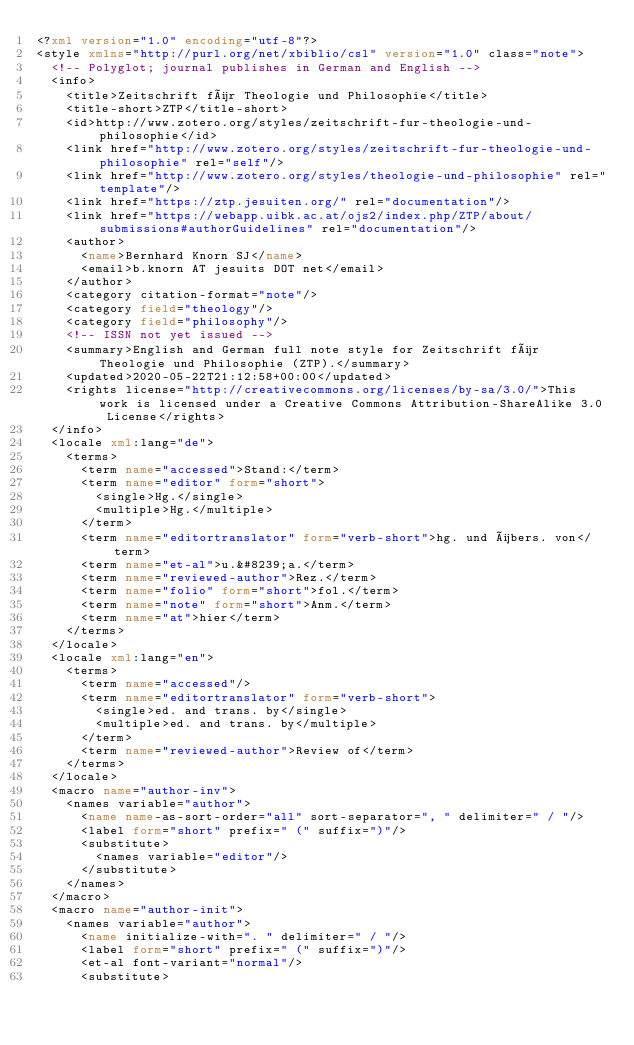<code> <loc_0><loc_0><loc_500><loc_500><_XML_><?xml version="1.0" encoding="utf-8"?>
<style xmlns="http://purl.org/net/xbiblio/csl" version="1.0" class="note">
  <!-- Polyglot; journal publishes in German and English -->
  <info>
    <title>Zeitschrift für Theologie und Philosophie</title>
    <title-short>ZTP</title-short>
    <id>http://www.zotero.org/styles/zeitschrift-fur-theologie-und-philosophie</id>
    <link href="http://www.zotero.org/styles/zeitschrift-fur-theologie-und-philosophie" rel="self"/>
    <link href="http://www.zotero.org/styles/theologie-und-philosophie" rel="template"/>
    <link href="https://ztp.jesuiten.org/" rel="documentation"/>
    <link href="https://webapp.uibk.ac.at/ojs2/index.php/ZTP/about/submissions#authorGuidelines" rel="documentation"/>
    <author>
      <name>Bernhard Knorn SJ</name>
      <email>b.knorn AT jesuits DOT net</email>
    </author>
    <category citation-format="note"/>
    <category field="theology"/>
    <category field="philosophy"/>
    <!-- ISSN not yet issued -->
    <summary>English and German full note style for Zeitschrift für Theologie und Philosophie (ZTP).</summary>
    <updated>2020-05-22T21:12:58+00:00</updated>
    <rights license="http://creativecommons.org/licenses/by-sa/3.0/">This work is licensed under a Creative Commons Attribution-ShareAlike 3.0 License</rights>
  </info>
  <locale xml:lang="de">
    <terms>
      <term name="accessed">Stand:</term>
      <term name="editor" form="short">
        <single>Hg.</single>
        <multiple>Hg.</multiple>
      </term>
      <term name="editortranslator" form="verb-short">hg. und übers. von</term>
      <term name="et-al">u.&#8239;a.</term>
      <term name="reviewed-author">Rez.</term>
      <term name="folio" form="short">fol.</term>
      <term name="note" form="short">Anm.</term>
      <term name="at">hier</term>
    </terms>
  </locale>
  <locale xml:lang="en">
    <terms>
      <term name="accessed"/>
      <term name="editortranslator" form="verb-short">
        <single>ed. and trans. by</single>
        <multiple>ed. and trans. by</multiple>
      </term>
      <term name="reviewed-author">Review of</term>
    </terms>
  </locale>
  <macro name="author-inv">
    <names variable="author">
      <name name-as-sort-order="all" sort-separator=", " delimiter=" / "/>
      <label form="short" prefix=" (" suffix=")"/>
      <substitute>
        <names variable="editor"/>
      </substitute>
    </names>
  </macro>
  <macro name="author-init">
    <names variable="author">
      <name initialize-with=". " delimiter=" / "/>
      <label form="short" prefix=" (" suffix=")"/>
      <et-al font-variant="normal"/>
      <substitute></code> 